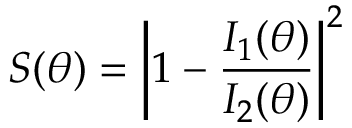<formula> <loc_0><loc_0><loc_500><loc_500>S ( \theta ) = \left | 1 - \frac { I _ { 1 } ( \theta ) } { I _ { 2 } ( \theta ) } \right | ^ { 2 }</formula> 